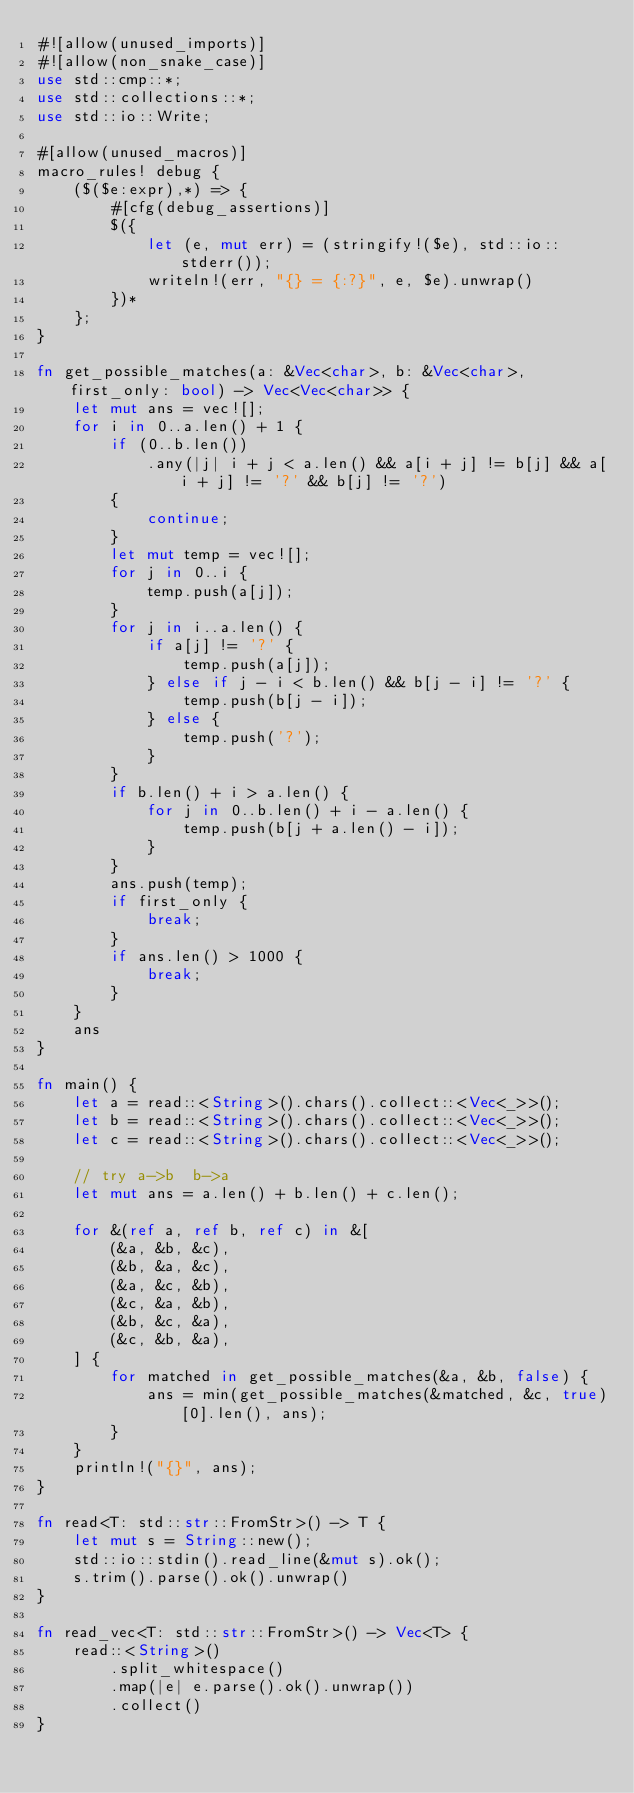<code> <loc_0><loc_0><loc_500><loc_500><_Rust_>#![allow(unused_imports)]
#![allow(non_snake_case)]
use std::cmp::*;
use std::collections::*;
use std::io::Write;

#[allow(unused_macros)]
macro_rules! debug {
    ($($e:expr),*) => {
        #[cfg(debug_assertions)]
        $({
            let (e, mut err) = (stringify!($e), std::io::stderr());
            writeln!(err, "{} = {:?}", e, $e).unwrap()
        })*
    };
}

fn get_possible_matches(a: &Vec<char>, b: &Vec<char>, first_only: bool) -> Vec<Vec<char>> {
    let mut ans = vec![];
    for i in 0..a.len() + 1 {
        if (0..b.len())
            .any(|j| i + j < a.len() && a[i + j] != b[j] && a[i + j] != '?' && b[j] != '?')
        {
            continue;
        }
        let mut temp = vec![];
        for j in 0..i {
            temp.push(a[j]);
        }
        for j in i..a.len() {
            if a[j] != '?' {
                temp.push(a[j]);
            } else if j - i < b.len() && b[j - i] != '?' {
                temp.push(b[j - i]);
            } else {
                temp.push('?');
            }
        }
        if b.len() + i > a.len() {
            for j in 0..b.len() + i - a.len() {
                temp.push(b[j + a.len() - i]);
            }
        }
        ans.push(temp);
        if first_only {
            break;
        }
        if ans.len() > 1000 {
            break;
        }
    }
    ans
}

fn main() {
    let a = read::<String>().chars().collect::<Vec<_>>();
    let b = read::<String>().chars().collect::<Vec<_>>();
    let c = read::<String>().chars().collect::<Vec<_>>();

    // try a->b  b->a
    let mut ans = a.len() + b.len() + c.len();

    for &(ref a, ref b, ref c) in &[
        (&a, &b, &c),
        (&b, &a, &c),
        (&a, &c, &b),
        (&c, &a, &b),
        (&b, &c, &a),
        (&c, &b, &a),
    ] {
        for matched in get_possible_matches(&a, &b, false) {
            ans = min(get_possible_matches(&matched, &c, true)[0].len(), ans);
        }
    }
    println!("{}", ans);
}

fn read<T: std::str::FromStr>() -> T {
    let mut s = String::new();
    std::io::stdin().read_line(&mut s).ok();
    s.trim().parse().ok().unwrap()
}

fn read_vec<T: std::str::FromStr>() -> Vec<T> {
    read::<String>()
        .split_whitespace()
        .map(|e| e.parse().ok().unwrap())
        .collect()
}
</code> 